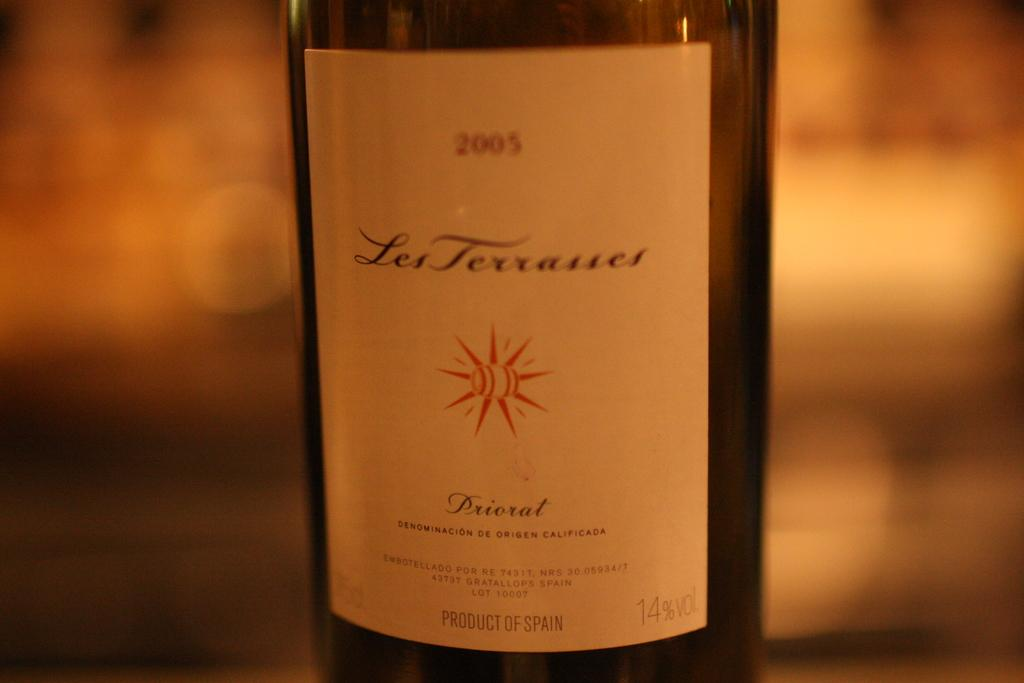<image>
Summarize the visual content of the image. The 2005 bottle of wine is a product of Spain. 